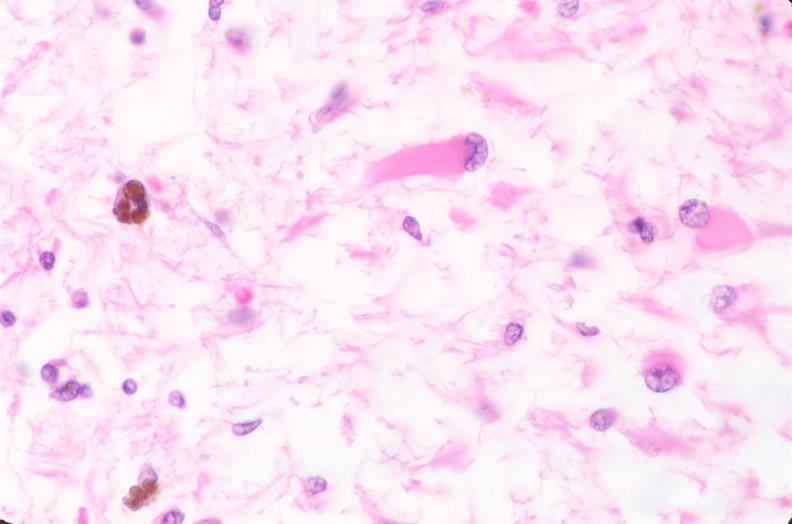why does this image show brain, infarct?
Answer the question using a single word or phrase. Due to ruptured saccular aneurysm and thrombosis of right middle cerebral artery plamacytic astrocytes 